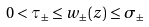Convert formula to latex. <formula><loc_0><loc_0><loc_500><loc_500>0 < \tau _ { \pm } \leq w _ { \pm } ( z ) \leq \sigma _ { \pm }</formula> 